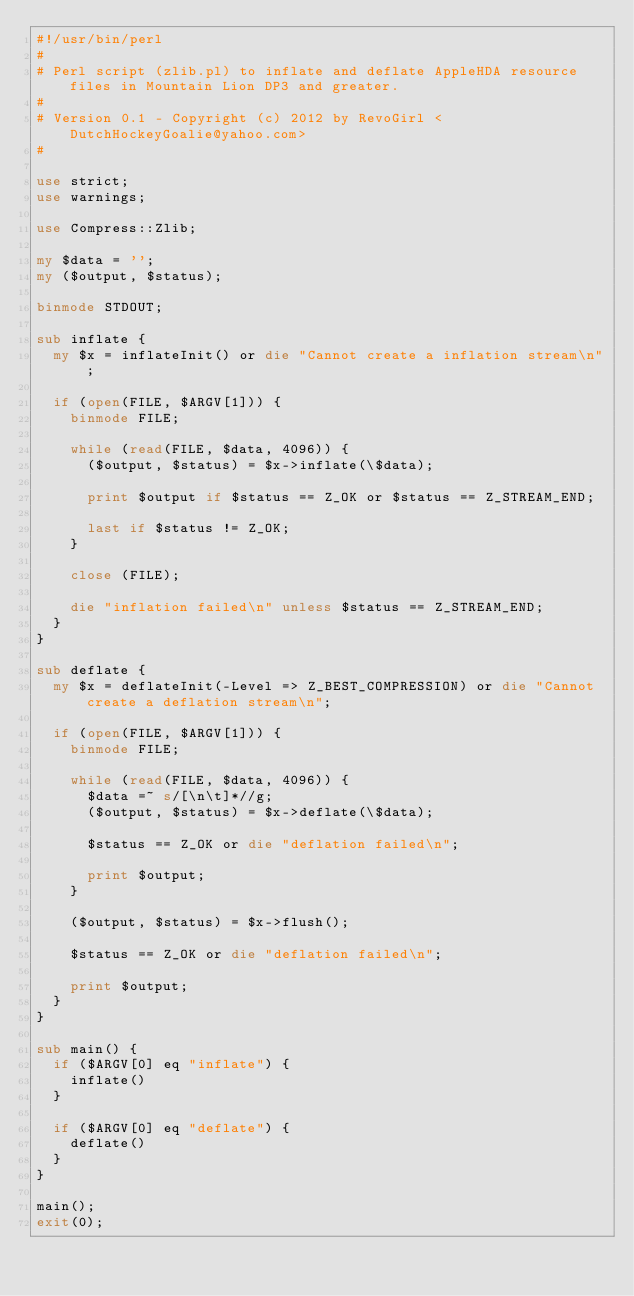<code> <loc_0><loc_0><loc_500><loc_500><_Perl_>#!/usr/bin/perl
#
# Perl script (zlib.pl) to inflate and deflate AppleHDA resource files in Mountain Lion DP3 and greater.
#
# Version 0.1 - Copyright (c) 2012 by RevoGirl <DutchHockeyGoalie@yahoo.com>
#

use strict;
use warnings;

use Compress::Zlib;

my $data = '';
my ($output, $status);

binmode STDOUT;

sub inflate {
	my $x = inflateInit() or die "Cannot create a inflation stream\n";

	if (open(FILE, $ARGV[1])) {
		binmode FILE;

		while (read(FILE, $data, 4096)) {
			($output, $status) = $x->inflate(\$data);

			print $output if $status == Z_OK or $status == Z_STREAM_END;

			last if $status != Z_OK;
		}

		close (FILE);

		die "inflation failed\n" unless $status == Z_STREAM_END;
	}
}

sub deflate {
	my $x = deflateInit(-Level => Z_BEST_COMPRESSION) or die "Cannot create a deflation stream\n";

	if (open(FILE, $ARGV[1])) {
		binmode FILE;

		while (read(FILE, $data, 4096)) {
			$data =~ s/[\n\t]*//g;
			($output, $status) = $x->deflate(\$data);

			$status == Z_OK or die "deflation failed\n";

			print $output;
		}
	
		($output, $status) = $x->flush();
	
		$status == Z_OK or die "deflation failed\n";

		print $output;
	}
}

sub main() {
	if ($ARGV[0] eq "inflate") {
		inflate()
	}
	
	if ($ARGV[0] eq "deflate") {
		deflate()
	}
}

main();
exit(0);
</code> 